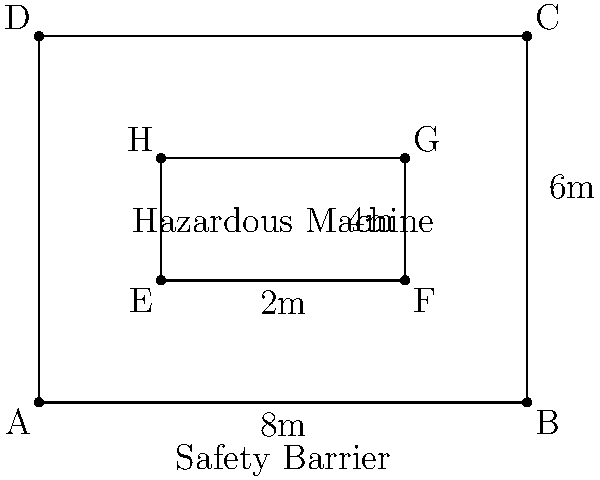A hazardous machine in your factory needs to be surrounded by a safety barrier. The machine is rectangular and measures 4m by 2m. The safety barrier must be placed 2m away from the machine on all sides. Calculate the perimeter of the safety barrier required to ensure worker safety. Let's approach this step-by-step:

1) First, we need to determine the dimensions of the safety barrier:
   - The machine is 4m long and 2m wide
   - The barrier needs to be 2m away from the machine on all sides
   
2) Calculate the length of the barrier:
   - Length of machine + 2m on each side
   - $4m + 2m + 2m = 8m$

3) Calculate the width of the barrier:
   - Width of machine + 2m on each side
   - $2m + 2m + 2m = 6m$

4) Now we have a rectangular barrier measuring 8m by 6m

5) To calculate the perimeter, we use the formula:
   $P = 2l + 2w$
   Where $P$ is perimeter, $l$ is length, and $w$ is width

6) Substituting our values:
   $P = 2(8m) + 2(6m)$
   $P = 16m + 12m$
   $P = 28m$

Therefore, the perimeter of the safety barrier is 28 meters.
Answer: 28m 